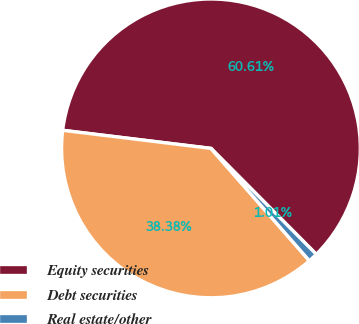<chart> <loc_0><loc_0><loc_500><loc_500><pie_chart><fcel>Equity securities<fcel>Debt securities<fcel>Real estate/other<nl><fcel>60.61%<fcel>38.38%<fcel>1.01%<nl></chart> 